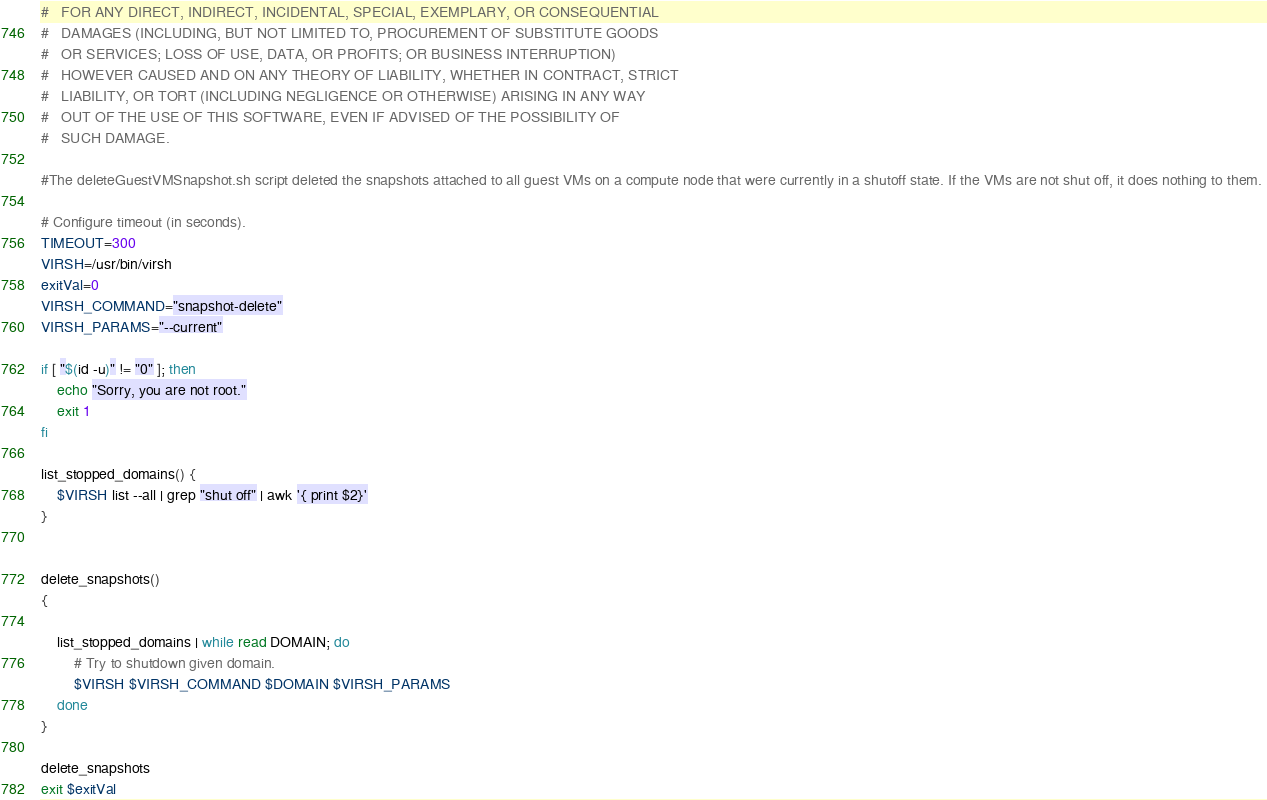<code> <loc_0><loc_0><loc_500><loc_500><_Bash_>#   FOR ANY DIRECT, INDIRECT, INCIDENTAL, SPECIAL, EXEMPLARY, OR CONSEQUENTIAL
#   DAMAGES (INCLUDING, BUT NOT LIMITED TO, PROCUREMENT OF SUBSTITUTE GOODS
#   OR SERVICES; LOSS OF USE, DATA, OR PROFITS; OR BUSINESS INTERRUPTION)
#   HOWEVER CAUSED AND ON ANY THEORY OF LIABILITY, WHETHER IN CONTRACT, STRICT
#   LIABILITY, OR TORT (INCLUDING NEGLIGENCE OR OTHERWISE) ARISING IN ANY WAY
#   OUT OF THE USE OF THIS SOFTWARE, EVEN IF ADVISED OF THE POSSIBILITY OF
#   SUCH DAMAGE.

#The deleteGuestVMSnapshot.sh script deleted the snapshots attached to all guest VMs on a compute node that were currently in a shutoff state. If the VMs are not shut off, it does nothing to them. 

# Configure timeout (in seconds).
TIMEOUT=300
VIRSH=/usr/bin/virsh
exitVal=0
VIRSH_COMMAND="snapshot-delete"
VIRSH_PARAMS="--current"

if [ "$(id -u)" != "0" ]; then
	echo "Sorry, you are not root."
	exit 1
fi

list_stopped_domains() {
	$VIRSH list --all | grep "shut off" | awk '{ print $2}'
}


delete_snapshots() 
{

	list_stopped_domains | while read DOMAIN; do
		# Try to shutdown given domain.
		$VIRSH $VIRSH_COMMAND $DOMAIN $VIRSH_PARAMS
	done
}

delete_snapshots
exit $exitVal
</code> 